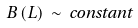<formula> <loc_0><loc_0><loc_500><loc_500>B \left ( L \right ) \, \sim \, c o n s t a n t</formula> 